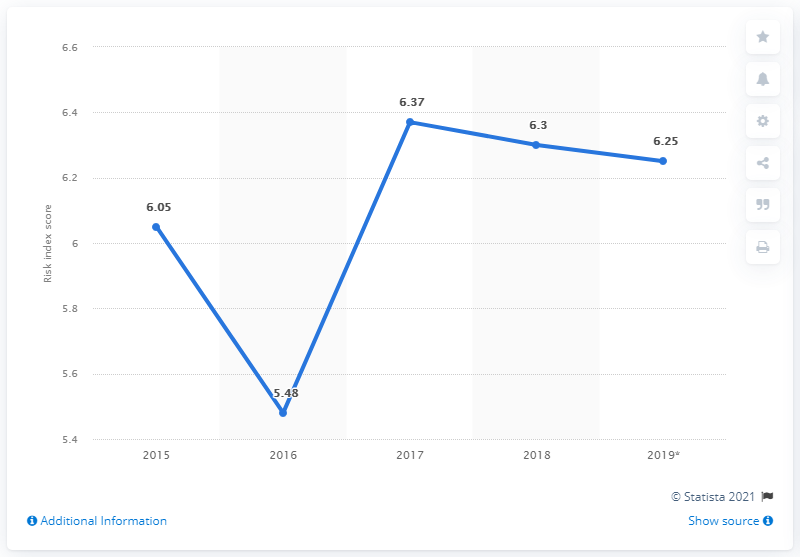Give some essential details in this illustration. In 2019, Ecuador's index score was 6.25. 